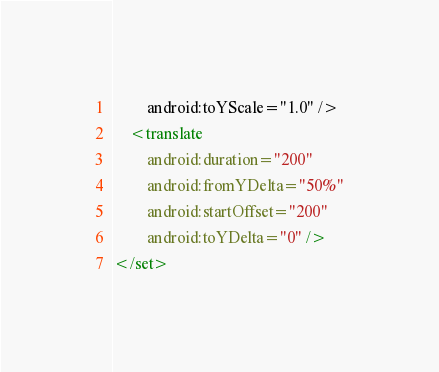Convert code to text. <code><loc_0><loc_0><loc_500><loc_500><_XML_>        android:toYScale="1.0" />
    <translate
        android:duration="200"
        android:fromYDelta="50%"
        android:startOffset="200"
        android:toYDelta="0" />
</set></code> 